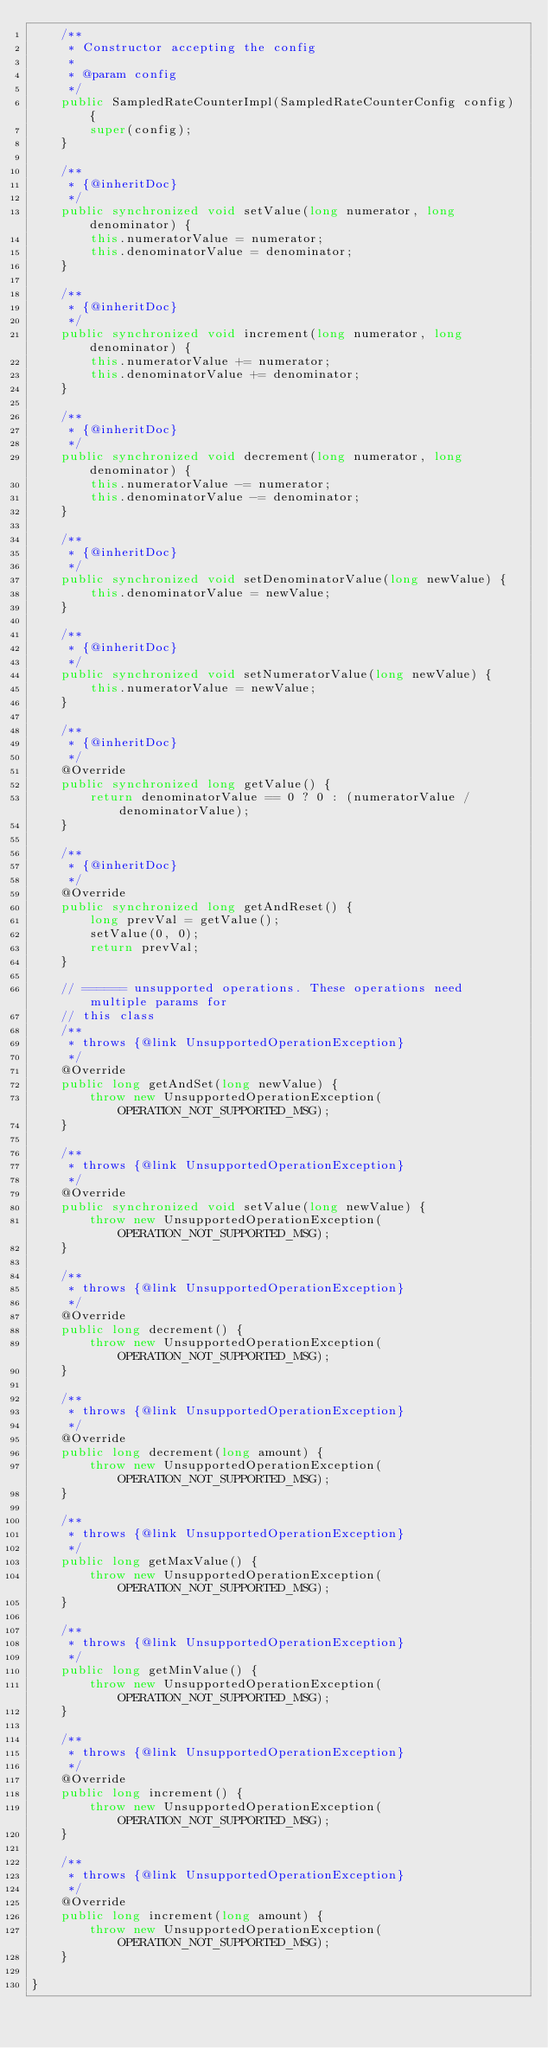<code> <loc_0><loc_0><loc_500><loc_500><_Java_>    /**
     * Constructor accepting the config
     * 
     * @param config
     */
    public SampledRateCounterImpl(SampledRateCounterConfig config) {
        super(config);
    }

    /**
     * {@inheritDoc}
     */
    public synchronized void setValue(long numerator, long denominator) {
        this.numeratorValue = numerator;
        this.denominatorValue = denominator;
    }

    /**
     * {@inheritDoc}
     */
    public synchronized void increment(long numerator, long denominator) {
        this.numeratorValue += numerator;
        this.denominatorValue += denominator;
    }

    /**
     * {@inheritDoc}
     */
    public synchronized void decrement(long numerator, long denominator) {
        this.numeratorValue -= numerator;
        this.denominatorValue -= denominator;
    }

    /**
     * {@inheritDoc}
     */
    public synchronized void setDenominatorValue(long newValue) {
        this.denominatorValue = newValue;
    }

    /**
     * {@inheritDoc}
     */
    public synchronized void setNumeratorValue(long newValue) {
        this.numeratorValue = newValue;
    }

    /**
     * {@inheritDoc}
     */
    @Override
    public synchronized long getValue() {
        return denominatorValue == 0 ? 0 : (numeratorValue / denominatorValue);
    }

    /**
     * {@inheritDoc}
     */
    @Override
    public synchronized long getAndReset() {
        long prevVal = getValue();
        setValue(0, 0);
        return prevVal;
    }

    // ====== unsupported operations. These operations need multiple params for
    // this class
    /**
     * throws {@link UnsupportedOperationException}
     */
    @Override
    public long getAndSet(long newValue) {
        throw new UnsupportedOperationException(OPERATION_NOT_SUPPORTED_MSG);
    }

    /**
     * throws {@link UnsupportedOperationException}
     */
    @Override
    public synchronized void setValue(long newValue) {
        throw new UnsupportedOperationException(OPERATION_NOT_SUPPORTED_MSG);
    }

    /**
     * throws {@link UnsupportedOperationException}
     */
    @Override
    public long decrement() {
        throw new UnsupportedOperationException(OPERATION_NOT_SUPPORTED_MSG);
    }

    /**
     * throws {@link UnsupportedOperationException}
     */
    @Override
    public long decrement(long amount) {
        throw new UnsupportedOperationException(OPERATION_NOT_SUPPORTED_MSG);
    }

    /**
     * throws {@link UnsupportedOperationException}
     */
    public long getMaxValue() {
        throw new UnsupportedOperationException(OPERATION_NOT_SUPPORTED_MSG);
    }

    /**
     * throws {@link UnsupportedOperationException}
     */
    public long getMinValue() {
        throw new UnsupportedOperationException(OPERATION_NOT_SUPPORTED_MSG);
    }

    /**
     * throws {@link UnsupportedOperationException}
     */
    @Override
    public long increment() {
        throw new UnsupportedOperationException(OPERATION_NOT_SUPPORTED_MSG);
    }

    /**
     * throws {@link UnsupportedOperationException}
     */
    @Override
    public long increment(long amount) {
        throw new UnsupportedOperationException(OPERATION_NOT_SUPPORTED_MSG);
    }

}
</code> 